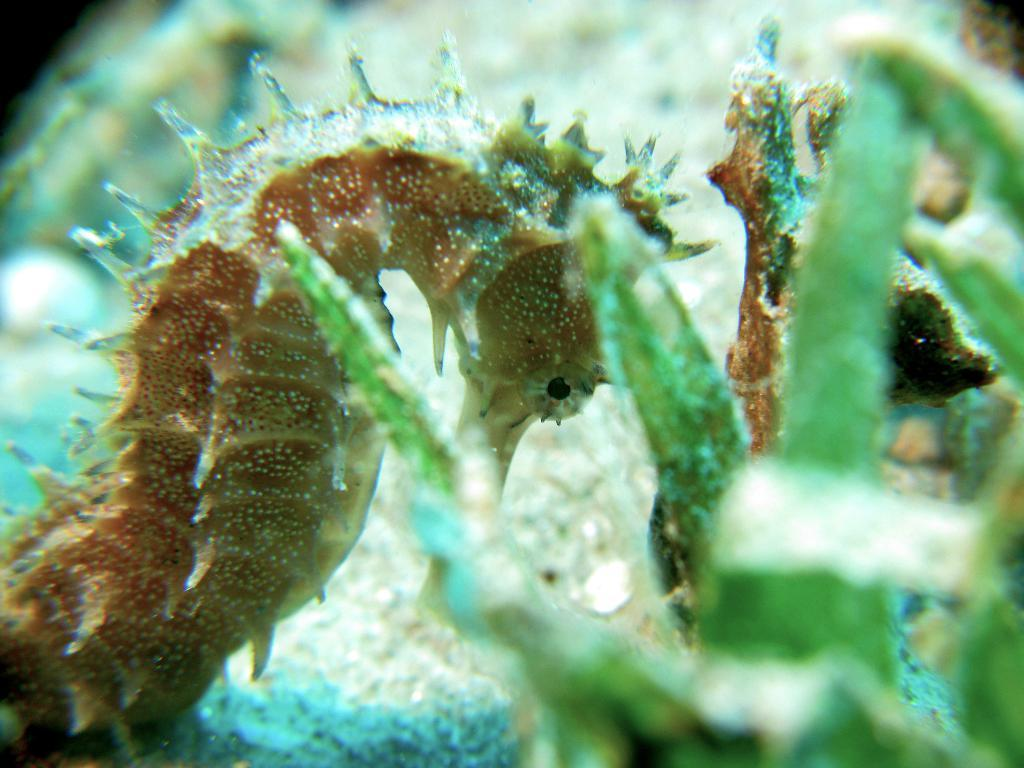What is the main subject in the foreground of the image? There is a seahorse in the foreground of the image. What else can be seen in the image besides the seahorse? There appears to be an aquatic plant in the image. What type of approval does the seahorse need to exist in the image? The seahorse does not need any approval to exist in the image; it is already present. Can you hear any thunder in the image? There is no mention of thunder or any sound in the image, as it is a still image. 